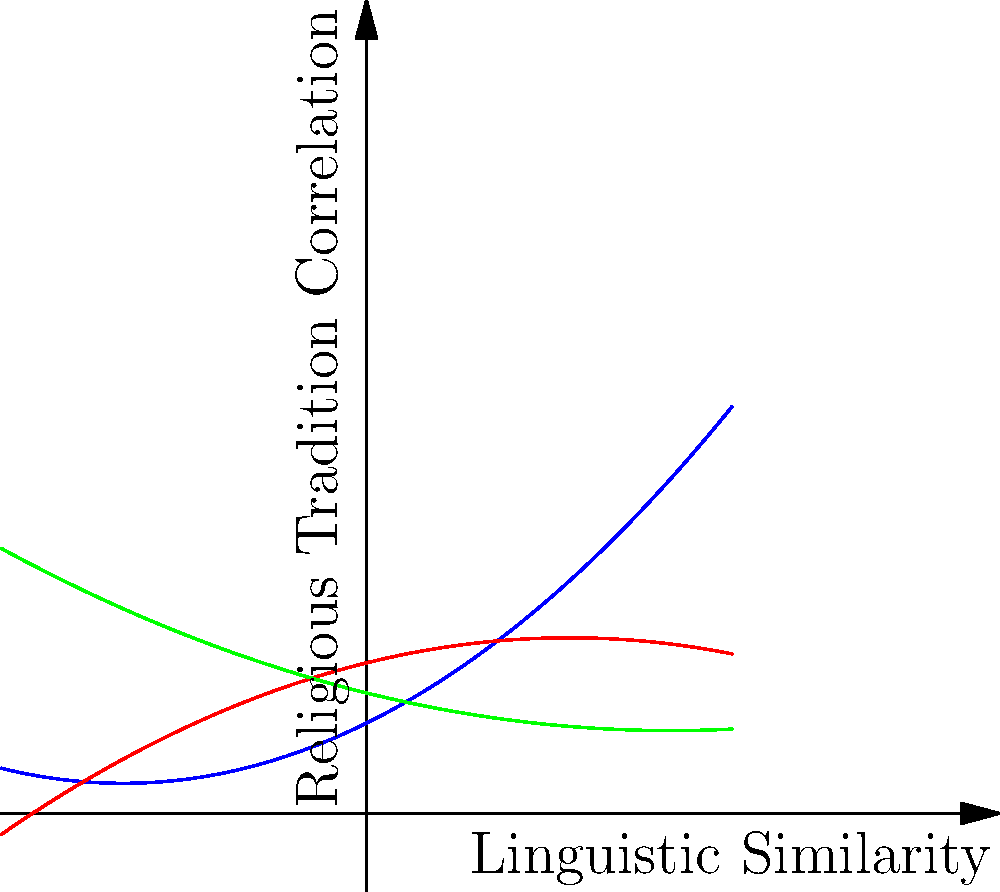Based on the polynomial trend lines representing the correlation between linguistic similarities and religious traditions in Slavic language groups, which group shows the highest positive correlation at the rightmost point of the graph, and what might this suggest about the relationship between language and religion in this group? To answer this question, we need to analyze the polynomial trend lines for each Slavic language group:

1. Identify the curves:
   - Blue curve: East Slavic
   - Red curve: West Slavic
   - Green curve: South Slavic

2. Examine the rightmost point of the graph (x ≈ 3):
   - East Slavic (blue) has the highest y-value
   - West Slavic (red) is the lowest
   - South Slavic (green) is in between

3. Interpret the graph:
   - The x-axis represents linguistic similarity
   - The y-axis represents correlation with religious traditions
   - A higher y-value indicates a stronger correlation

4. Analyze the East Slavic trend:
   - The curve is a positive parabola (opens upward)
   - It shows the strongest positive correlation at x ≈ 3
   - This suggests that as linguistic similarity increases, so does the correlation with religious traditions

5. Consider the implications:
   - East Slavic languages (Russian, Ukrainian, Belarusian) might have a stronger connection between their linguistic features and religious practices
   - This could be due to historical factors, such as the influence of the Orthodox Church on language and culture in these regions

6. Critically evaluate:
   - Remember that this is a simplified model and may not capture all nuances
   - Other factors, such as political and social influences, are not represented here
   - As a scholar with mild skepticism towards reconstructionist movements, consider how this data might be interpreted or misinterpreted in that context
Answer: East Slavic; suggests stronger language-religion connection in this group. 